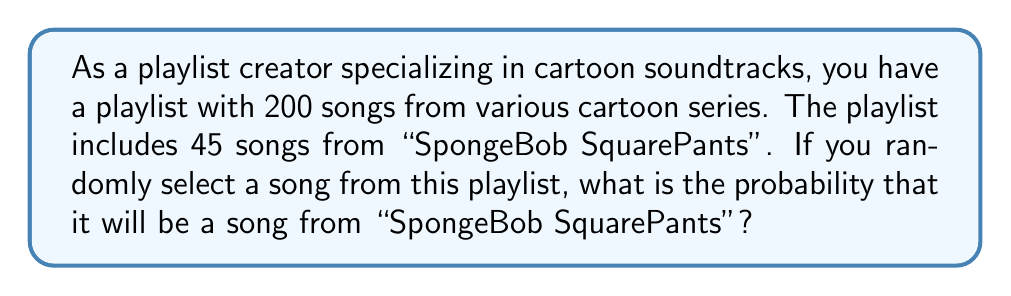What is the answer to this math problem? To solve this problem, we need to use the concept of probability for a single event. The probability of an event occurring is the number of favorable outcomes divided by the total number of possible outcomes, assuming all outcomes are equally likely.

Let's define our variables:
- Total number of songs in the playlist: $n = 200$
- Number of songs from "SpongeBob SquarePants": $k = 45$

The probability of selecting a SpongeBob song is:

$$P(\text{SpongeBob song}) = \frac{\text{Number of SpongeBob songs}}{\text{Total number of songs}}$$

Substituting our values:

$$P(\text{SpongeBob song}) = \frac{k}{n} = \frac{45}{200}$$

To simplify this fraction, we can divide both the numerator and denominator by their greatest common divisor (GCD). The GCD of 45 and 200 is 5.

$$\frac{45}{200} = \frac{45 \div 5}{200 \div 5} = \frac{9}{40}$$

Therefore, the probability of randomly selecting a SpongeBob song from the playlist is $\frac{9}{40}$.
Answer: $\frac{9}{40}$ or $0.225$ or $22.5\%$ 